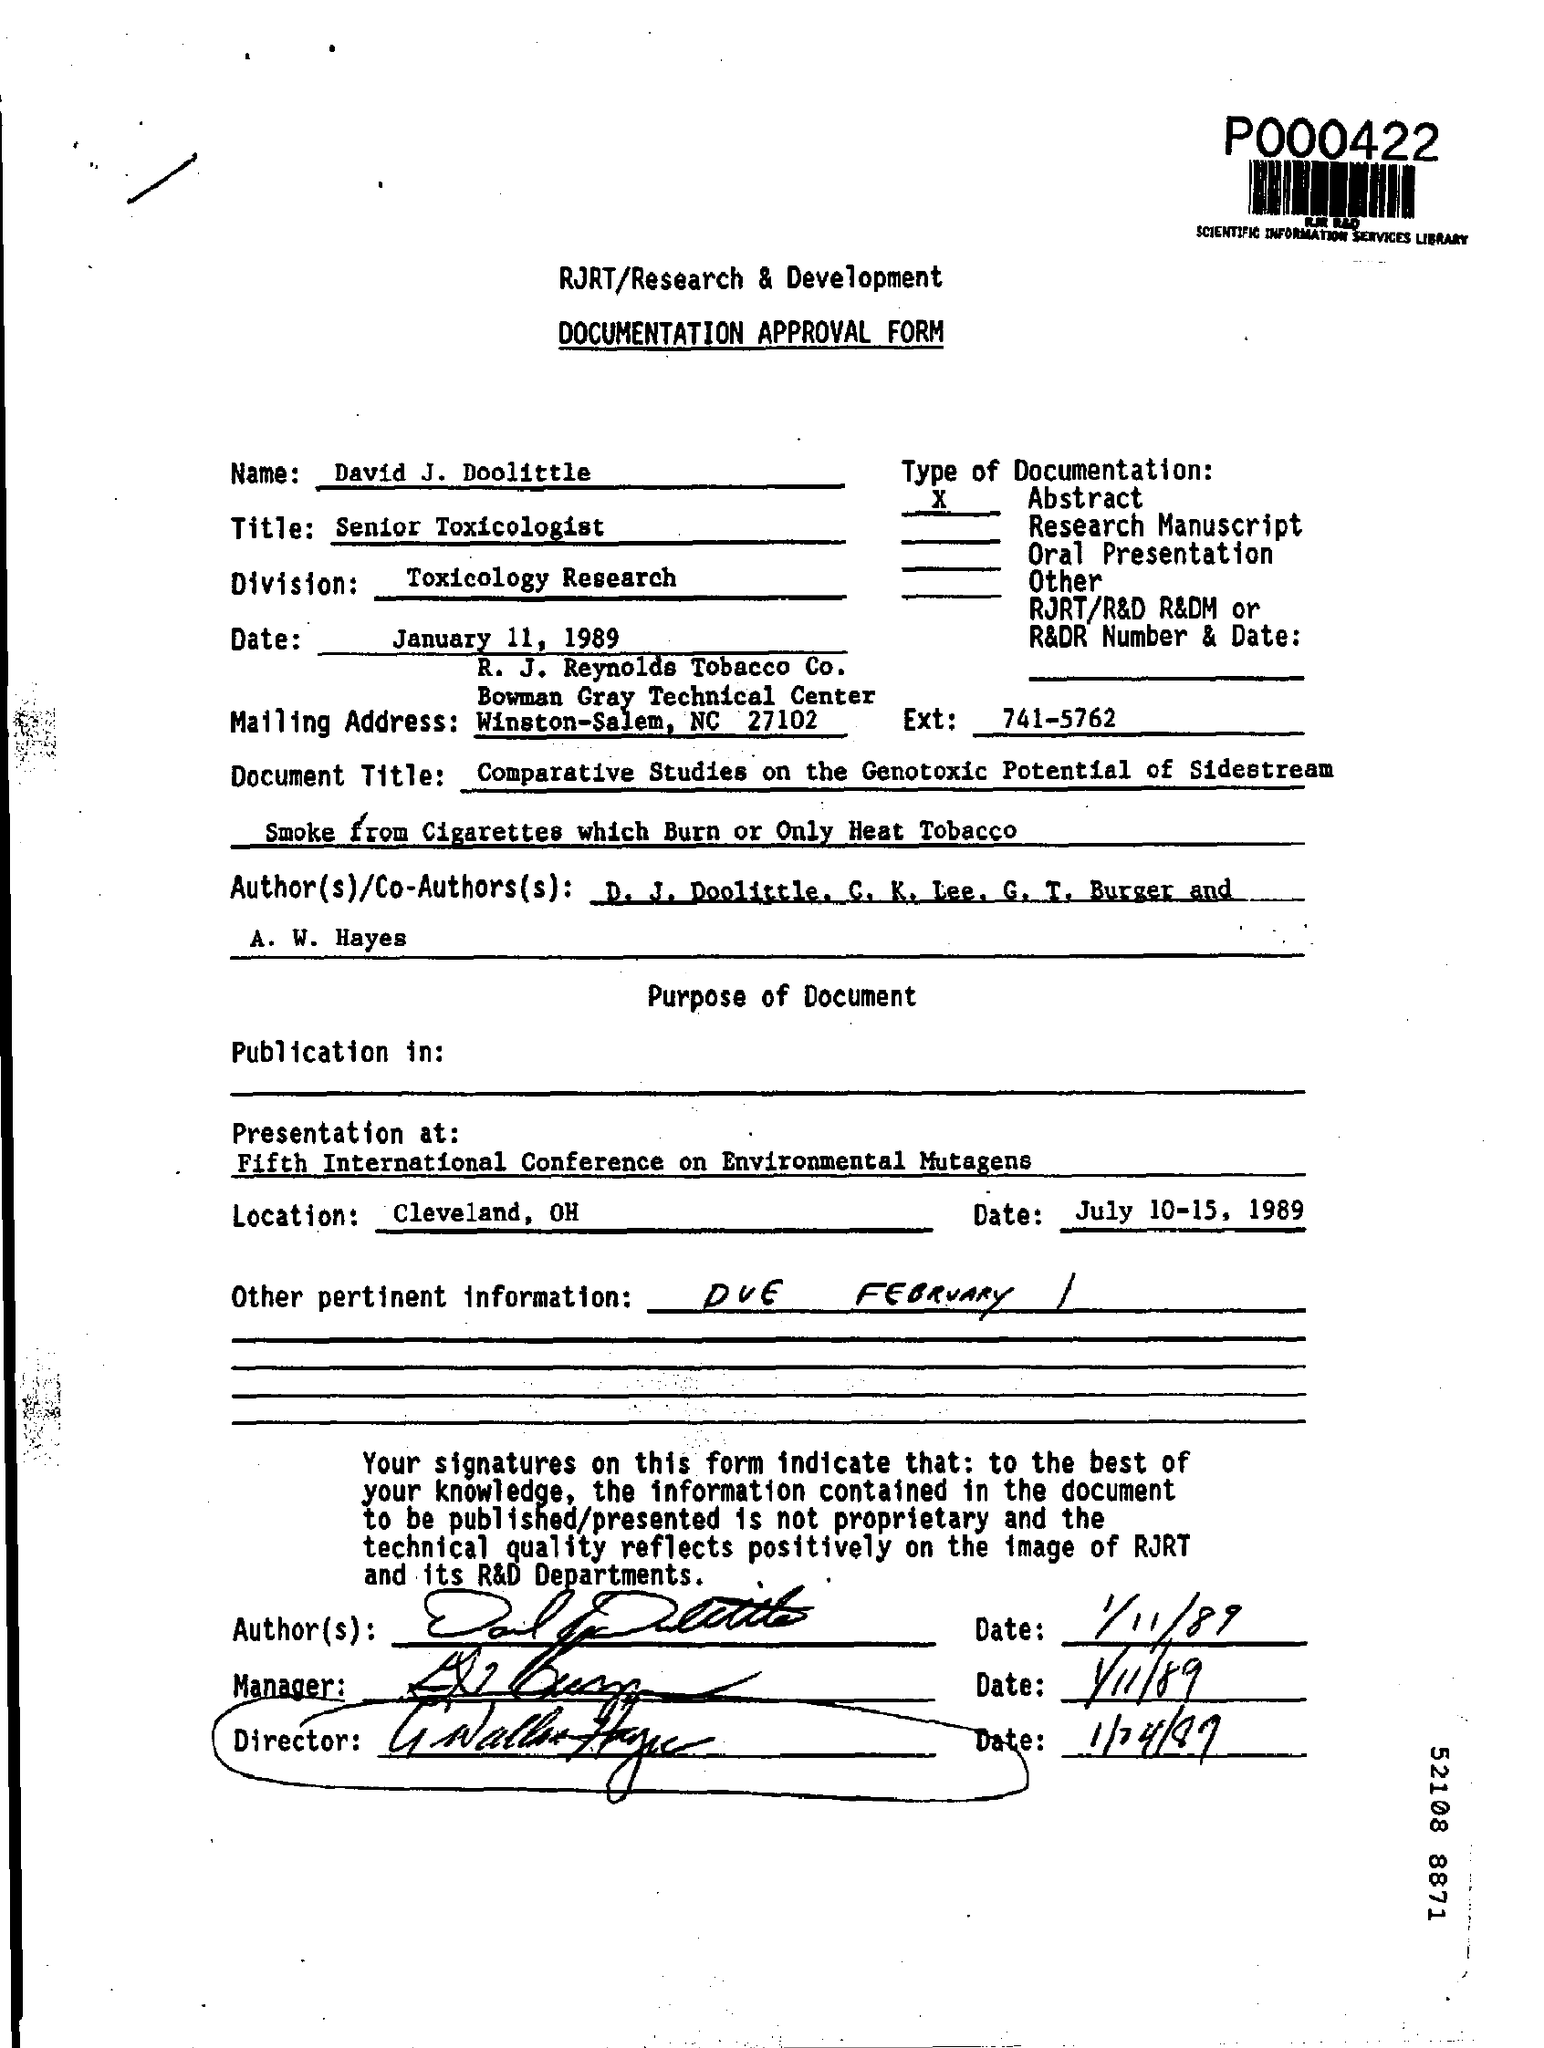What is the name mentioned ?
Your answer should be very brief. DAVID J. DOOLITTLE. What is the location of the presentation ?
Provide a succinct answer. Cleveland , OH. What is mentioned in the ext ?
Your answer should be compact. 741-5762. What is mentioned in the other pertinent information ?
Keep it short and to the point. Due February. What is the date mentioned ?
Your answer should be very brief. January 11 , 1989. 